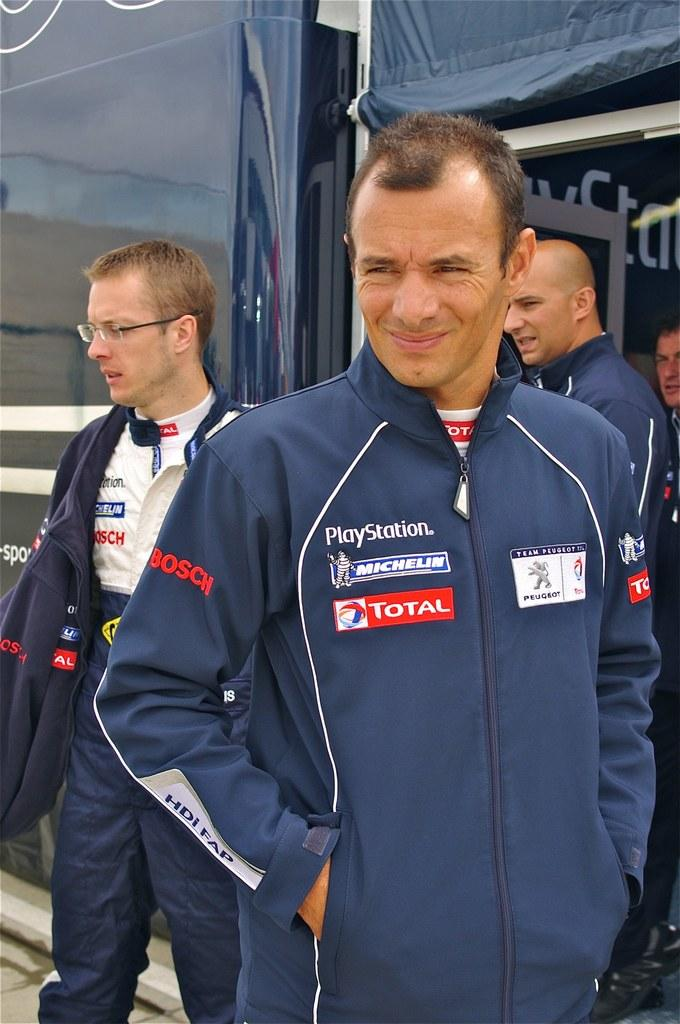<image>
Render a clear and concise summary of the photo. A group of people in car racing coveralls that says Playstation 3 on them. 